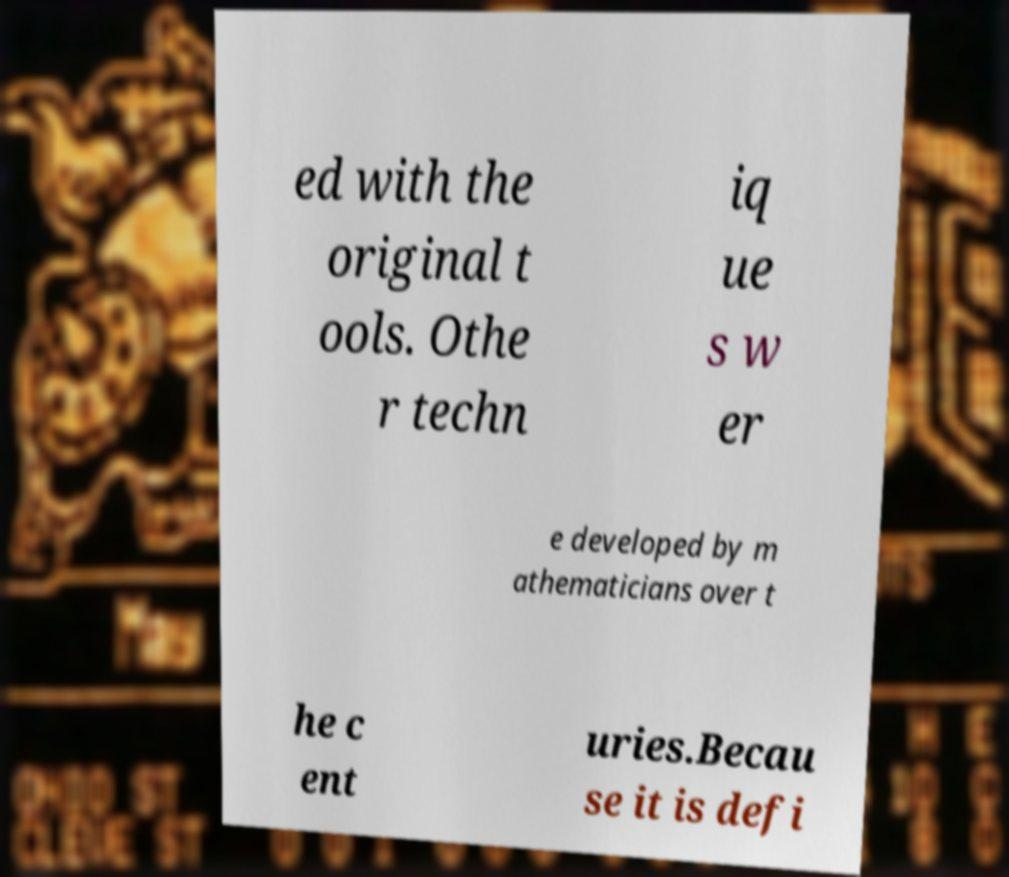Could you extract and type out the text from this image? ed with the original t ools. Othe r techn iq ue s w er e developed by m athematicians over t he c ent uries.Becau se it is defi 